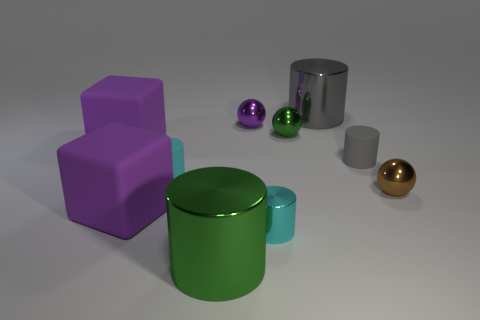Are there an equal number of small brown objects behind the large green metallic cylinder and cubes that are in front of the tiny gray thing?
Keep it short and to the point. Yes. There is a small cyan object that is on the left side of the small purple metallic object; is it the same shape as the small gray rubber object?
Keep it short and to the point. Yes. What number of green things are cylinders or small balls?
Give a very brief answer. 2. There is a green object that is the same shape as the tiny purple object; what is its material?
Give a very brief answer. Metal. What shape is the green shiny object behind the green cylinder?
Your response must be concise. Sphere. Is there a green sphere made of the same material as the small green thing?
Your answer should be very brief. No. Do the cyan metal object and the purple metal object have the same size?
Ensure brevity in your answer.  Yes. What number of balls are purple metal things or gray metal things?
Your answer should be compact. 1. What material is the thing that is the same color as the tiny metal cylinder?
Ensure brevity in your answer.  Rubber. How many other objects are the same shape as the tiny cyan shiny object?
Offer a very short reply. 4. 